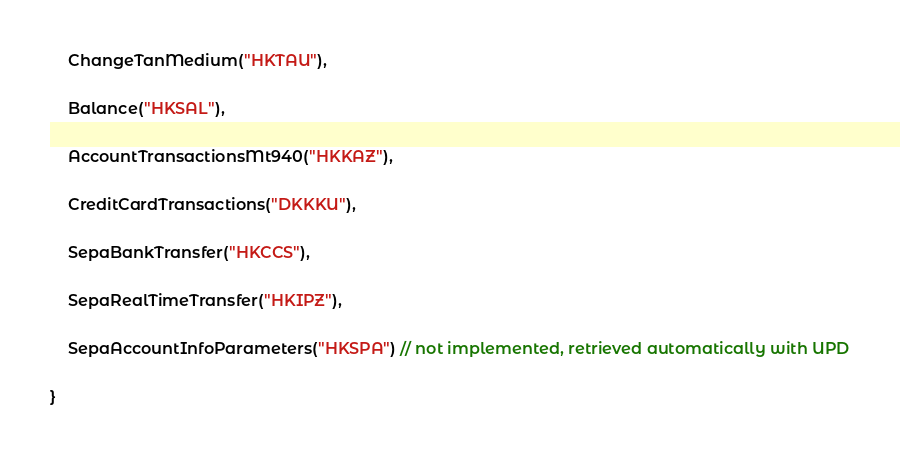Convert code to text. <code><loc_0><loc_0><loc_500><loc_500><_Kotlin_>    ChangeTanMedium("HKTAU"),

    Balance("HKSAL"),

    AccountTransactionsMt940("HKKAZ"),

    CreditCardTransactions("DKKKU"),

    SepaBankTransfer("HKCCS"),

    SepaRealTimeTransfer("HKIPZ"),

    SepaAccountInfoParameters("HKSPA") // not implemented, retrieved automatically with UPD

}</code> 